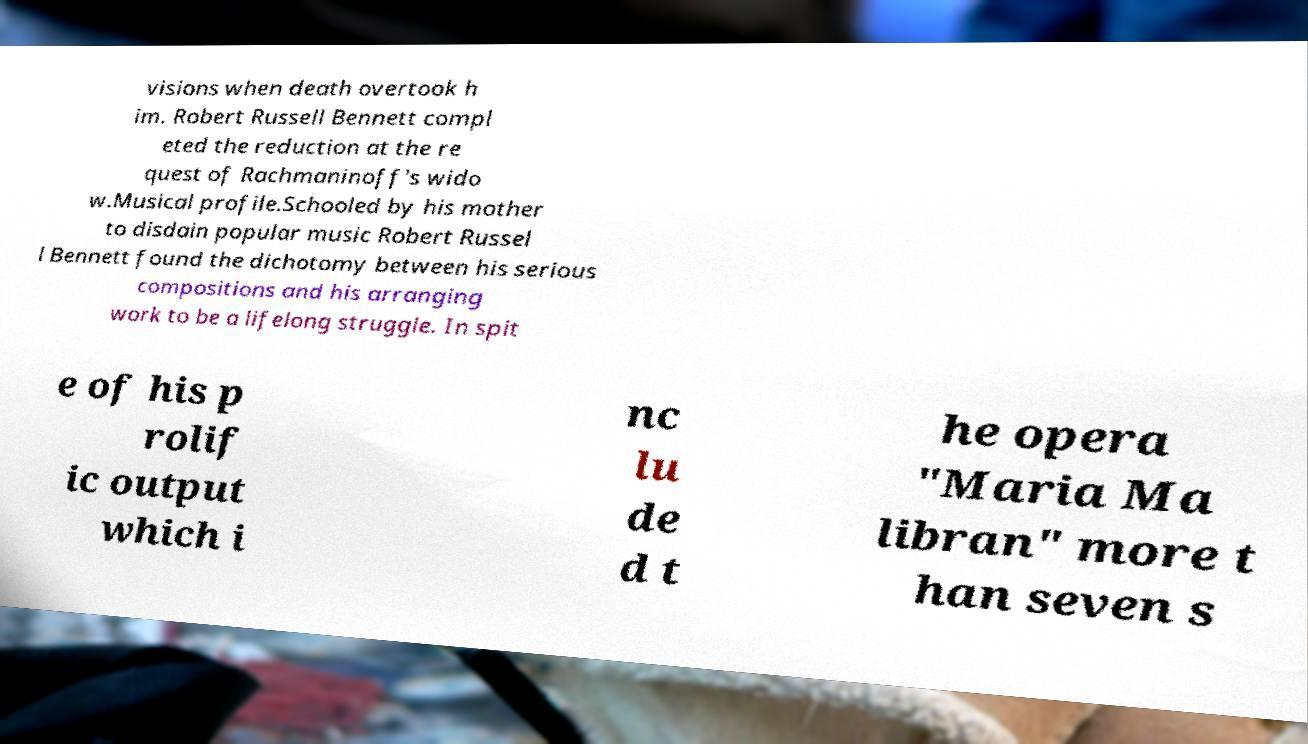I need the written content from this picture converted into text. Can you do that? visions when death overtook h im. Robert Russell Bennett compl eted the reduction at the re quest of Rachmaninoff's wido w.Musical profile.Schooled by his mother to disdain popular music Robert Russel l Bennett found the dichotomy between his serious compositions and his arranging work to be a lifelong struggle. In spit e of his p rolif ic output which i nc lu de d t he opera "Maria Ma libran" more t han seven s 